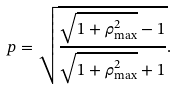Convert formula to latex. <formula><loc_0><loc_0><loc_500><loc_500>p = \sqrt { \frac { \sqrt { 1 + \rho _ { \max } ^ { 2 } } - 1 } { \sqrt { 1 + \rho _ { \max } ^ { 2 } } + 1 } } .</formula> 